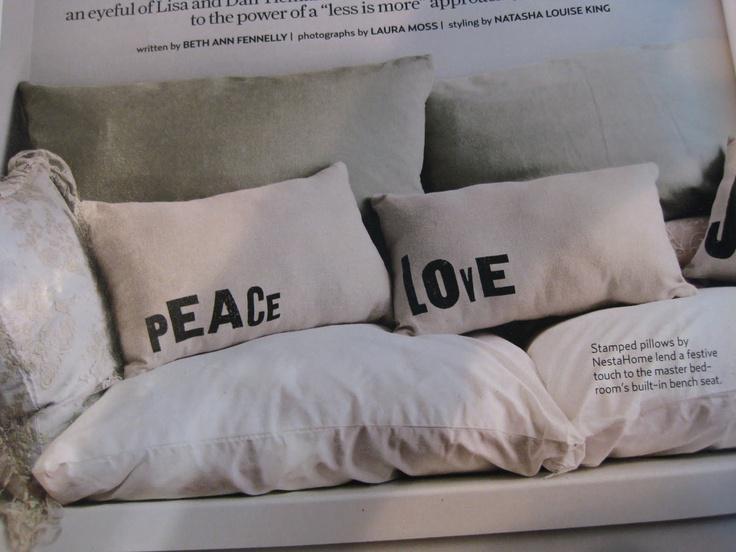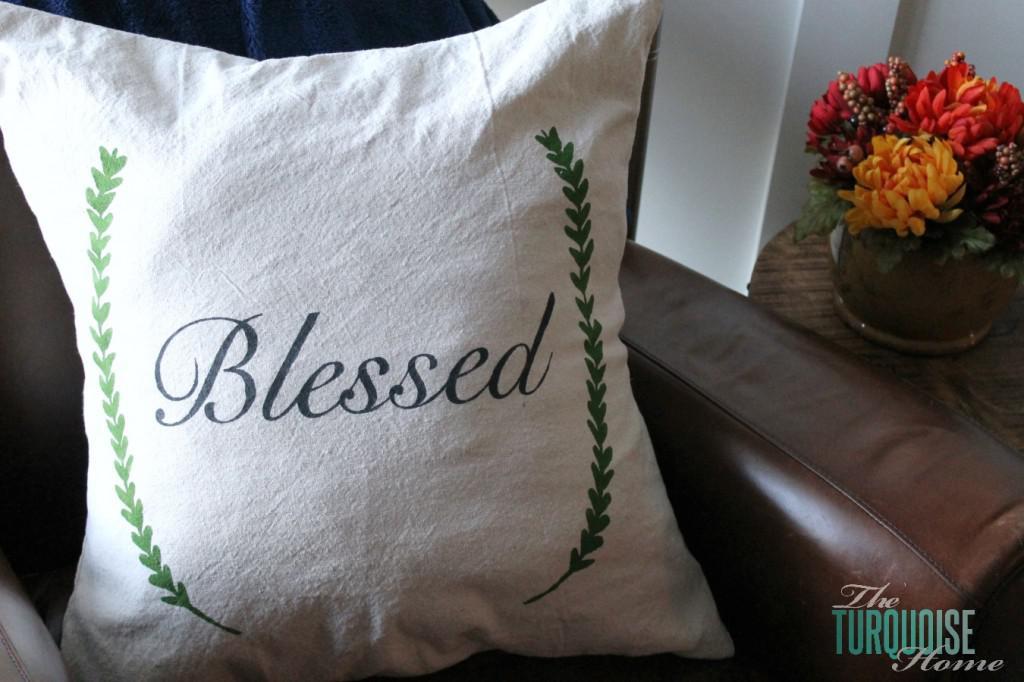The first image is the image on the left, the second image is the image on the right. Considering the images on both sides, is "There are two pillow on top of a brown surface." valid? Answer yes or no. No. The first image is the image on the left, the second image is the image on the right. For the images displayed, is the sentence "Pillows in each image have printed images or words on them." factually correct? Answer yes or no. Yes. 